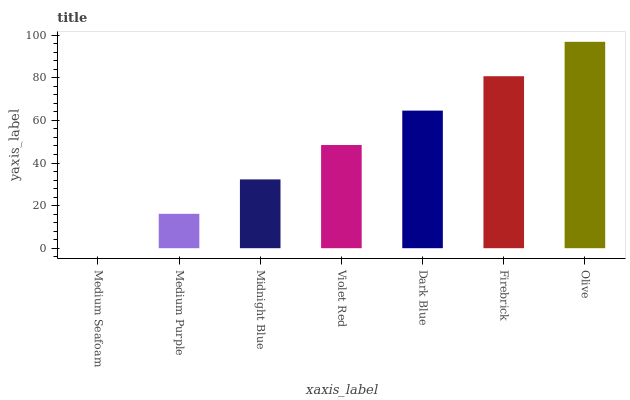Is Medium Purple the minimum?
Answer yes or no. No. Is Medium Purple the maximum?
Answer yes or no. No. Is Medium Purple greater than Medium Seafoam?
Answer yes or no. Yes. Is Medium Seafoam less than Medium Purple?
Answer yes or no. Yes. Is Medium Seafoam greater than Medium Purple?
Answer yes or no. No. Is Medium Purple less than Medium Seafoam?
Answer yes or no. No. Is Violet Red the high median?
Answer yes or no. Yes. Is Violet Red the low median?
Answer yes or no. Yes. Is Medium Purple the high median?
Answer yes or no. No. Is Olive the low median?
Answer yes or no. No. 